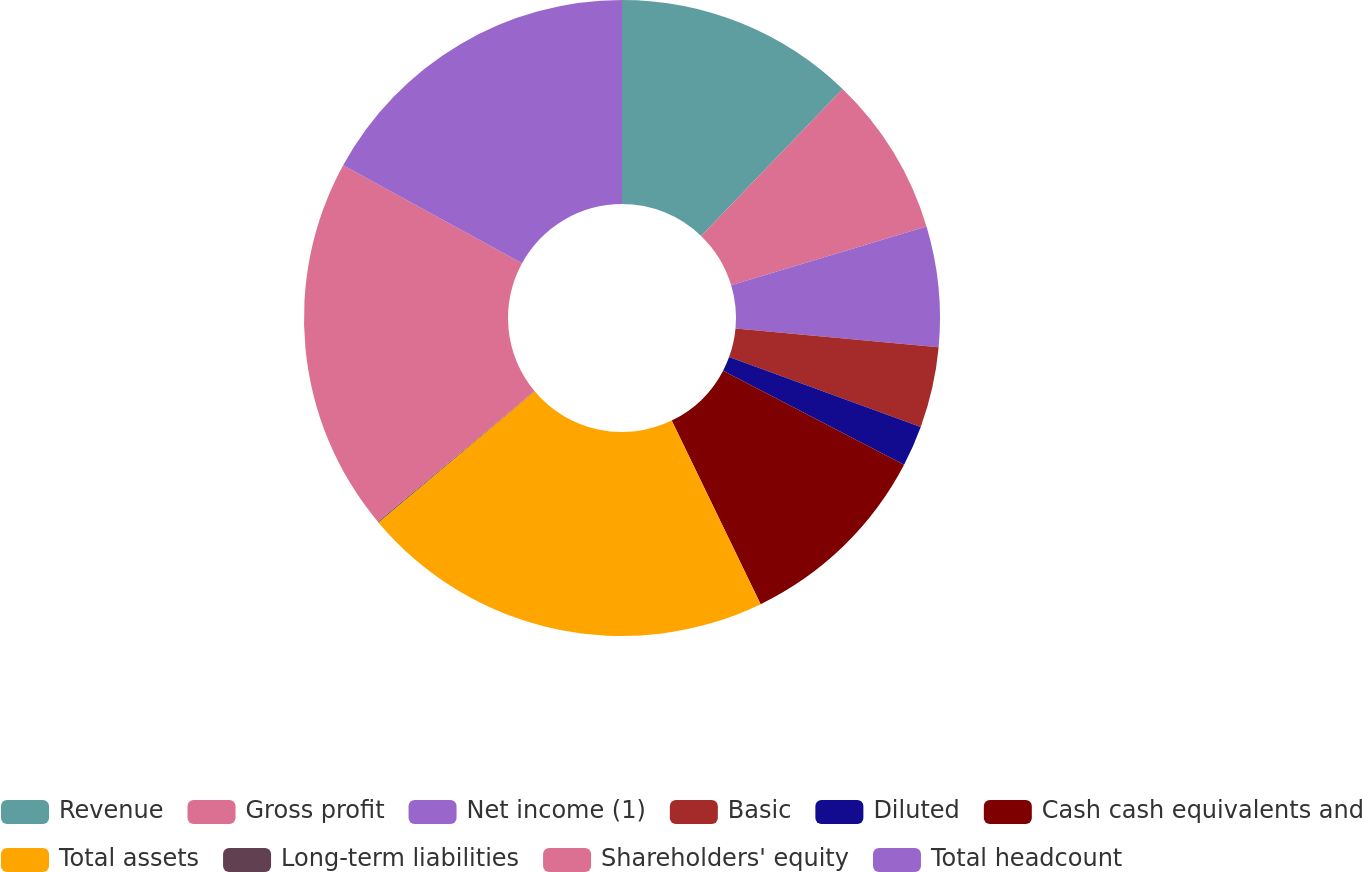Convert chart to OTSL. <chart><loc_0><loc_0><loc_500><loc_500><pie_chart><fcel>Revenue<fcel>Gross profit<fcel>Net income (1)<fcel>Basic<fcel>Diluted<fcel>Cash cash equivalents and<fcel>Total assets<fcel>Long-term liabilities<fcel>Shareholders' equity<fcel>Total headcount<nl><fcel>12.2%<fcel>8.15%<fcel>6.12%<fcel>4.1%<fcel>2.07%<fcel>10.18%<fcel>21.07%<fcel>0.04%<fcel>19.05%<fcel>17.02%<nl></chart> 